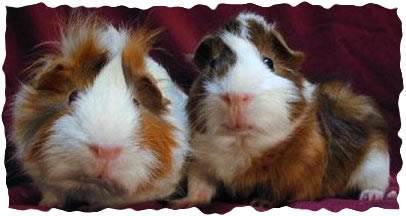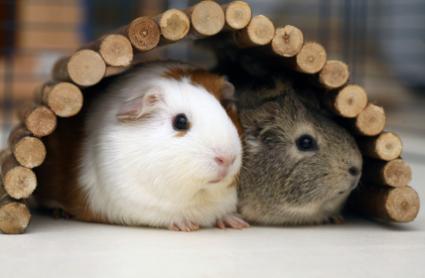The first image is the image on the left, the second image is the image on the right. Evaluate the accuracy of this statement regarding the images: "No image contains more than two guinea pigs, and one image features two multi-color guinea pigs posed side-by-side and facing straight ahead.". Is it true? Answer yes or no. Yes. The first image is the image on the left, the second image is the image on the right. Analyze the images presented: Is the assertion "One images shows only one guinea pig and the other shows at least two." valid? Answer yes or no. No. 